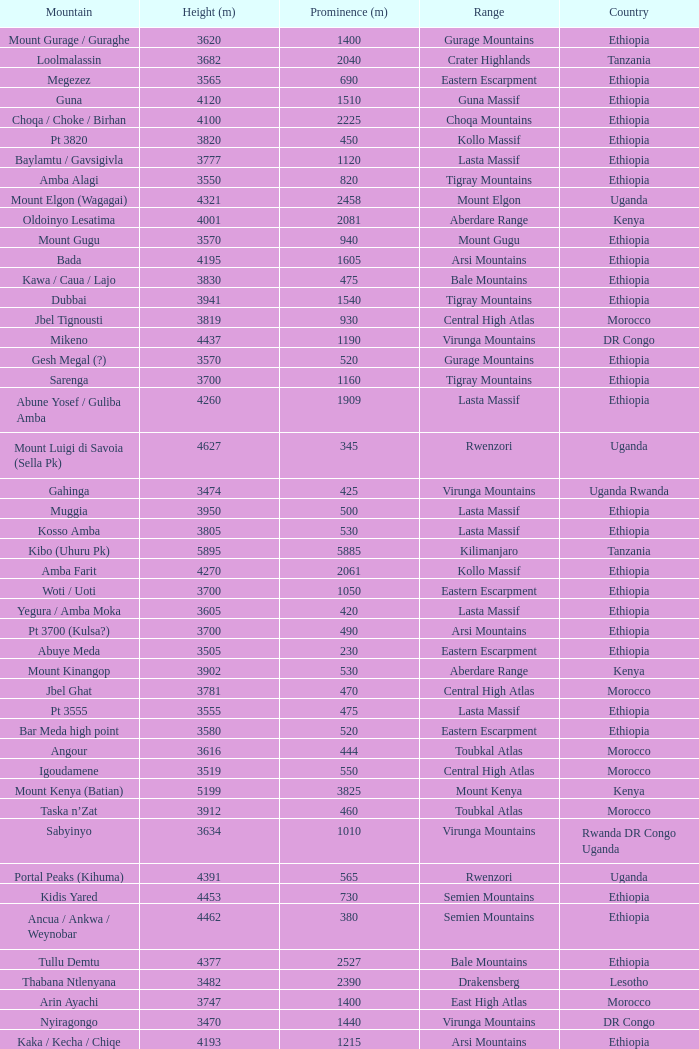How tall is the Mountain of jbel ghat? 1.0. 